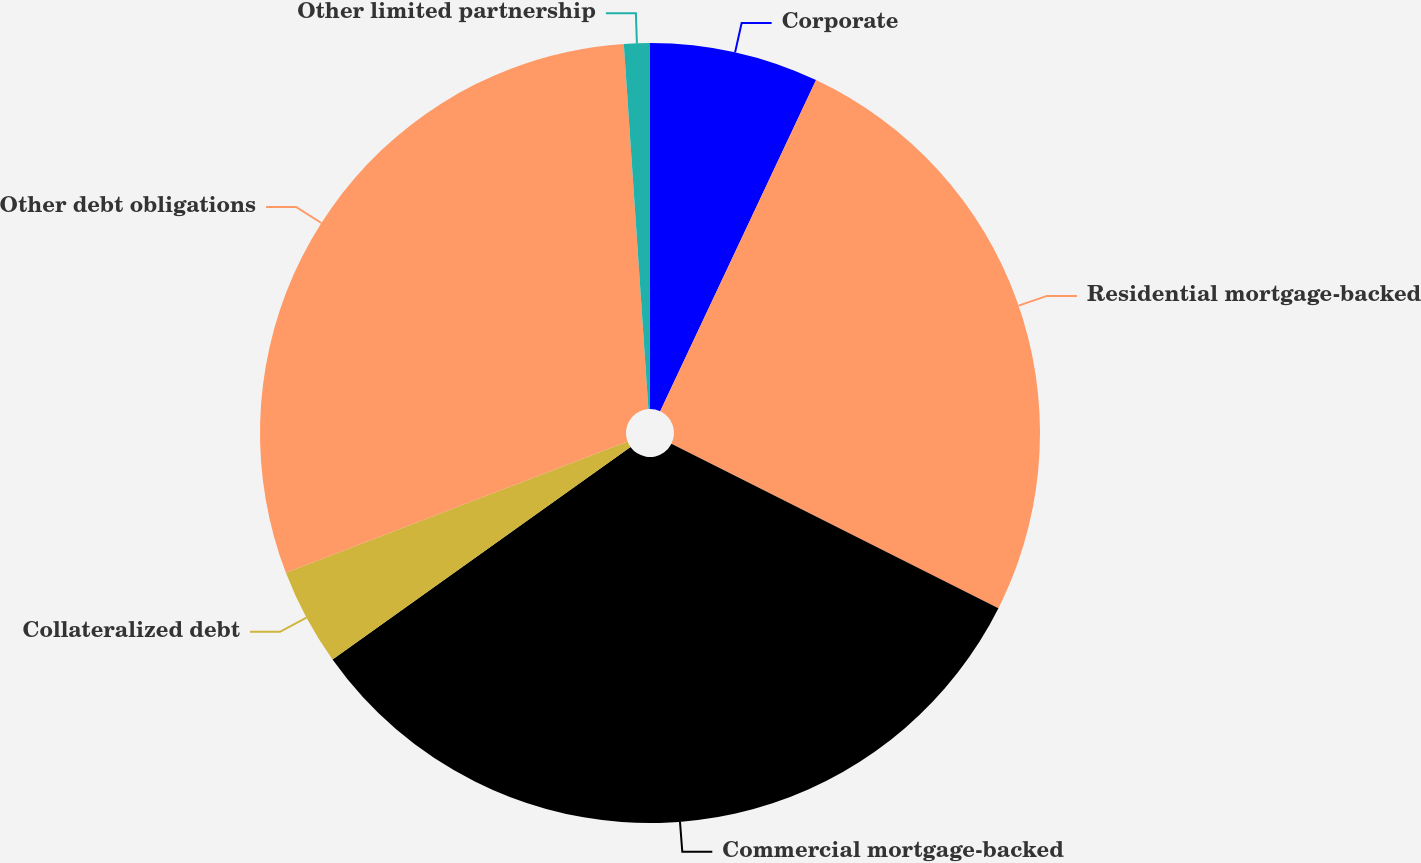Convert chart to OTSL. <chart><loc_0><loc_0><loc_500><loc_500><pie_chart><fcel>Corporate<fcel>Residential mortgage-backed<fcel>Commercial mortgage-backed<fcel>Collateralized debt<fcel>Other debt obligations<fcel>Other limited partnership<nl><fcel>7.0%<fcel>25.41%<fcel>32.72%<fcel>4.03%<fcel>29.76%<fcel>1.07%<nl></chart> 